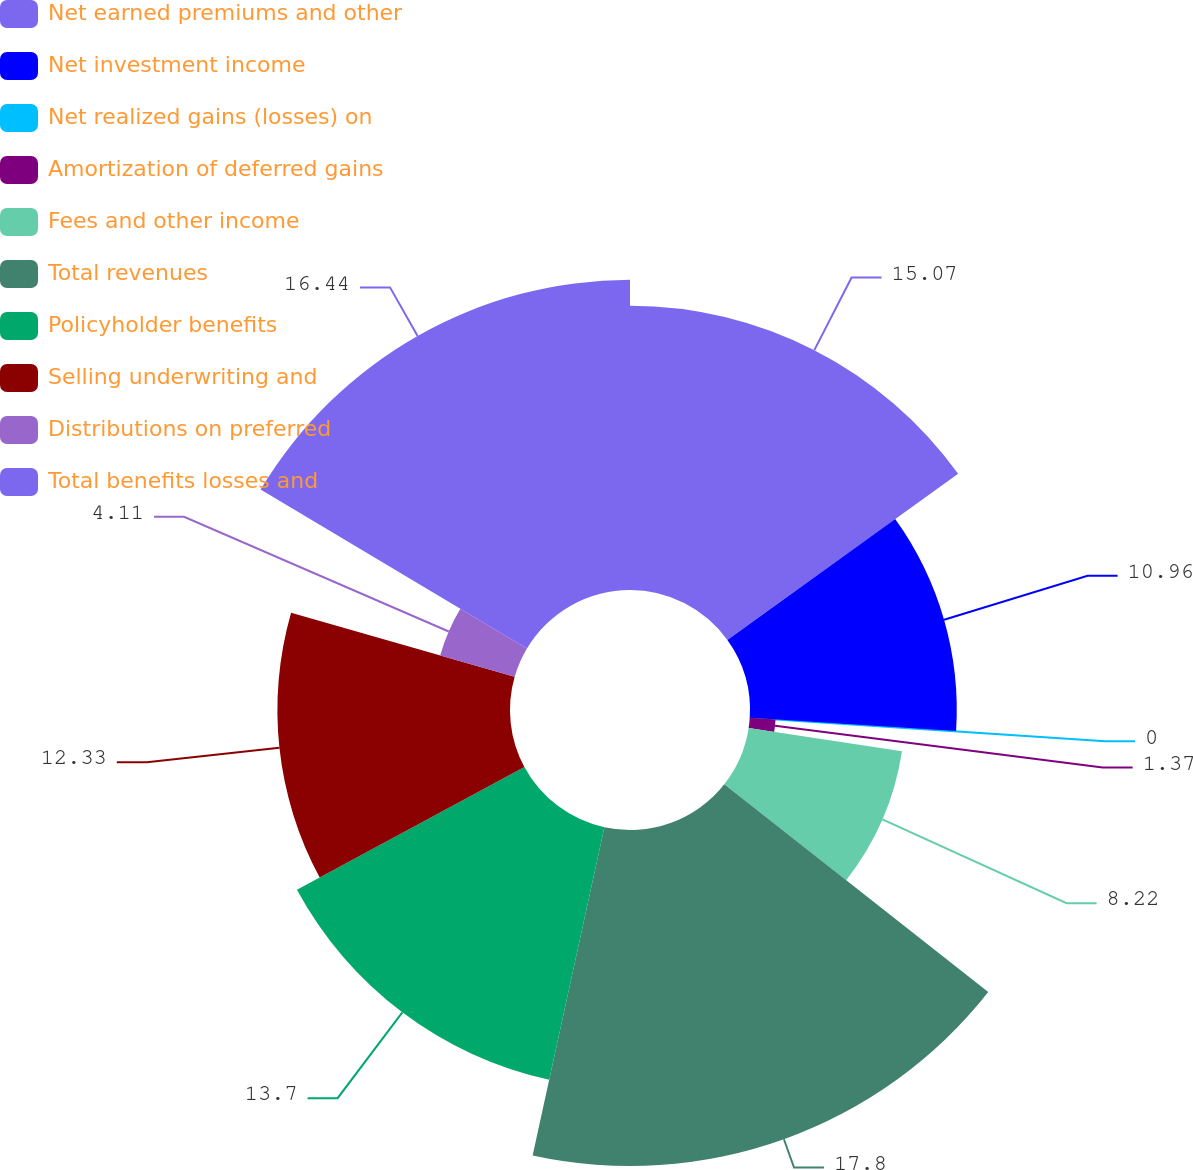Convert chart. <chart><loc_0><loc_0><loc_500><loc_500><pie_chart><fcel>Net earned premiums and other<fcel>Net investment income<fcel>Net realized gains (losses) on<fcel>Amortization of deferred gains<fcel>Fees and other income<fcel>Total revenues<fcel>Policyholder benefits<fcel>Selling underwriting and<fcel>Distributions on preferred<fcel>Total benefits losses and<nl><fcel>15.07%<fcel>10.96%<fcel>0.0%<fcel>1.37%<fcel>8.22%<fcel>17.81%<fcel>13.7%<fcel>12.33%<fcel>4.11%<fcel>16.44%<nl></chart> 